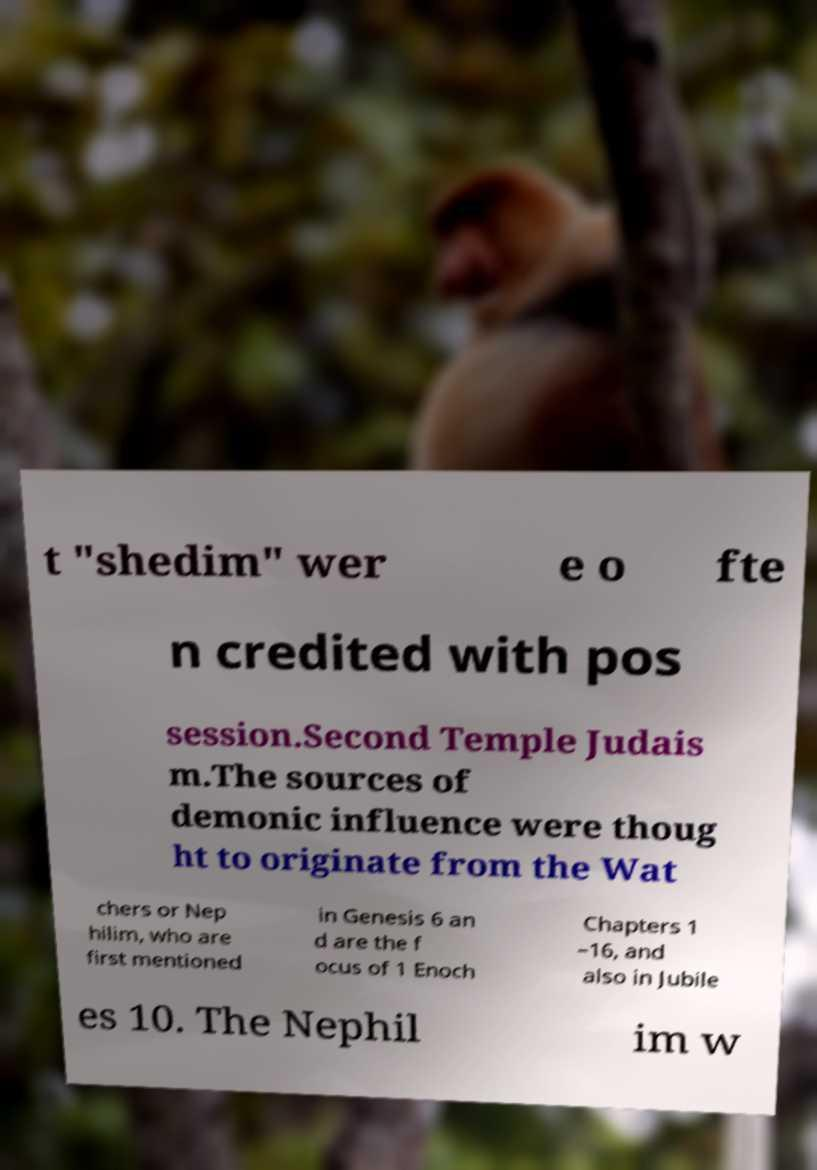There's text embedded in this image that I need extracted. Can you transcribe it verbatim? t "shedim" wer e o fte n credited with pos session.Second Temple Judais m.The sources of demonic influence were thoug ht to originate from the Wat chers or Nep hilim, who are first mentioned in Genesis 6 an d are the f ocus of 1 Enoch Chapters 1 –16, and also in Jubile es 10. The Nephil im w 